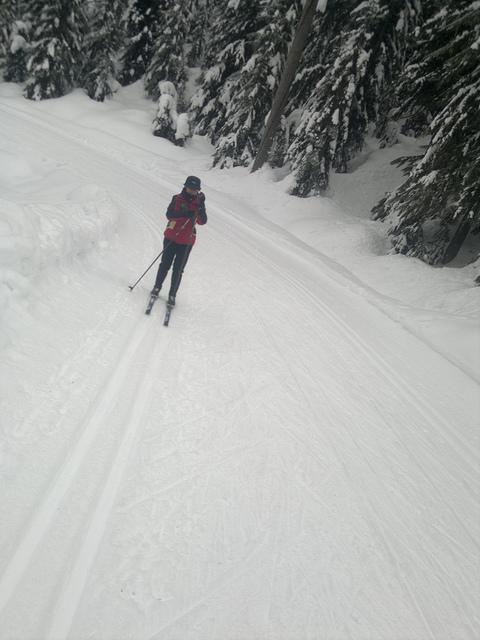How many yellow bottles are there?
Give a very brief answer. 0. 